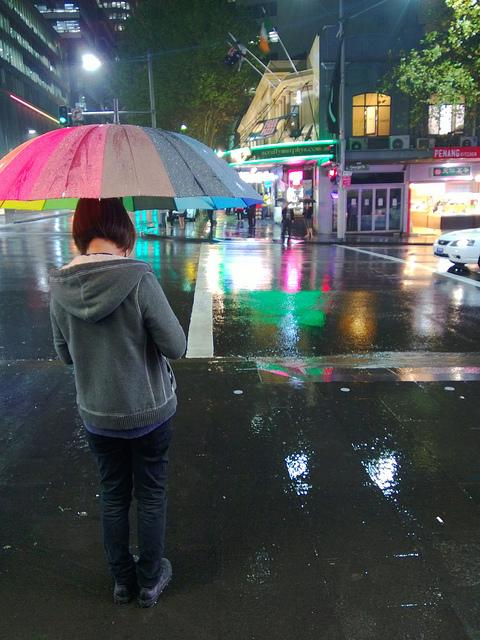What does the person standing here wait to see? ride 